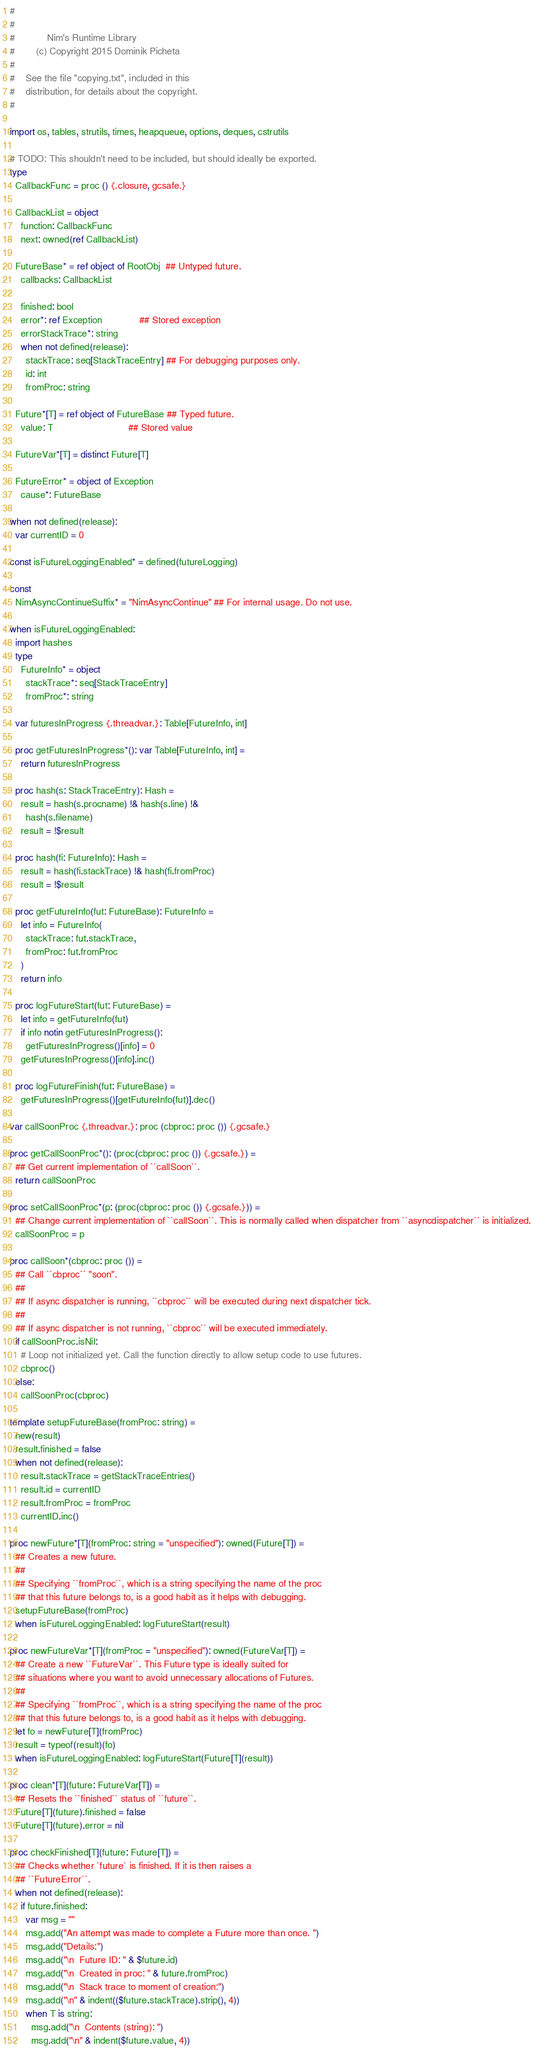<code> <loc_0><loc_0><loc_500><loc_500><_Nim_>#
#
#            Nim's Runtime Library
#        (c) Copyright 2015 Dominik Picheta
#
#    See the file "copying.txt", included in this
#    distribution, for details about the copyright.
#

import os, tables, strutils, times, heapqueue, options, deques, cstrutils

# TODO: This shouldn't need to be included, but should ideally be exported.
type
  CallbackFunc = proc () {.closure, gcsafe.}

  CallbackList = object
    function: CallbackFunc
    next: owned(ref CallbackList)

  FutureBase* = ref object of RootObj  ## Untyped future.
    callbacks: CallbackList

    finished: bool
    error*: ref Exception              ## Stored exception
    errorStackTrace*: string
    when not defined(release):
      stackTrace: seq[StackTraceEntry] ## For debugging purposes only.
      id: int
      fromProc: string

  Future*[T] = ref object of FutureBase ## Typed future.
    value: T                            ## Stored value

  FutureVar*[T] = distinct Future[T]

  FutureError* = object of Exception
    cause*: FutureBase

when not defined(release):
  var currentID = 0

const isFutureLoggingEnabled* = defined(futureLogging)

const
  NimAsyncContinueSuffix* = "NimAsyncContinue" ## For internal usage. Do not use.

when isFutureLoggingEnabled:
  import hashes
  type
    FutureInfo* = object
      stackTrace*: seq[StackTraceEntry]
      fromProc*: string

  var futuresInProgress {.threadvar.}: Table[FutureInfo, int]

  proc getFuturesInProgress*(): var Table[FutureInfo, int] =
    return futuresInProgress

  proc hash(s: StackTraceEntry): Hash =
    result = hash(s.procname) !& hash(s.line) !&
      hash(s.filename)
    result = !$result

  proc hash(fi: FutureInfo): Hash =
    result = hash(fi.stackTrace) !& hash(fi.fromProc)
    result = !$result

  proc getFutureInfo(fut: FutureBase): FutureInfo =
    let info = FutureInfo(
      stackTrace: fut.stackTrace,
      fromProc: fut.fromProc
    )
    return info

  proc logFutureStart(fut: FutureBase) =
    let info = getFutureInfo(fut)
    if info notin getFuturesInProgress():
      getFuturesInProgress()[info] = 0
    getFuturesInProgress()[info].inc()

  proc logFutureFinish(fut: FutureBase) =
    getFuturesInProgress()[getFutureInfo(fut)].dec()

var callSoonProc {.threadvar.}: proc (cbproc: proc ()) {.gcsafe.}

proc getCallSoonProc*(): (proc(cbproc: proc ()) {.gcsafe.}) =
  ## Get current implementation of ``callSoon``.
  return callSoonProc

proc setCallSoonProc*(p: (proc(cbproc: proc ()) {.gcsafe.})) =
  ## Change current implementation of ``callSoon``. This is normally called when dispatcher from ``asyncdispatcher`` is initialized.
  callSoonProc = p

proc callSoon*(cbproc: proc ()) =
  ## Call ``cbproc`` "soon".
  ##
  ## If async dispatcher is running, ``cbproc`` will be executed during next dispatcher tick.
  ##
  ## If async dispatcher is not running, ``cbproc`` will be executed immediately.
  if callSoonProc.isNil:
    # Loop not initialized yet. Call the function directly to allow setup code to use futures.
    cbproc()
  else:
    callSoonProc(cbproc)

template setupFutureBase(fromProc: string) =
  new(result)
  result.finished = false
  when not defined(release):
    result.stackTrace = getStackTraceEntries()
    result.id = currentID
    result.fromProc = fromProc
    currentID.inc()

proc newFuture*[T](fromProc: string = "unspecified"): owned(Future[T]) =
  ## Creates a new future.
  ##
  ## Specifying ``fromProc``, which is a string specifying the name of the proc
  ## that this future belongs to, is a good habit as it helps with debugging.
  setupFutureBase(fromProc)
  when isFutureLoggingEnabled: logFutureStart(result)

proc newFutureVar*[T](fromProc = "unspecified"): owned(FutureVar[T]) =
  ## Create a new ``FutureVar``. This Future type is ideally suited for
  ## situations where you want to avoid unnecessary allocations of Futures.
  ##
  ## Specifying ``fromProc``, which is a string specifying the name of the proc
  ## that this future belongs to, is a good habit as it helps with debugging.
  let fo = newFuture[T](fromProc)
  result = typeof(result)(fo)
  when isFutureLoggingEnabled: logFutureStart(Future[T](result))

proc clean*[T](future: FutureVar[T]) =
  ## Resets the ``finished`` status of ``future``.
  Future[T](future).finished = false
  Future[T](future).error = nil

proc checkFinished[T](future: Future[T]) =
  ## Checks whether `future` is finished. If it is then raises a
  ## ``FutureError``.
  when not defined(release):
    if future.finished:
      var msg = ""
      msg.add("An attempt was made to complete a Future more than once. ")
      msg.add("Details:")
      msg.add("\n  Future ID: " & $future.id)
      msg.add("\n  Created in proc: " & future.fromProc)
      msg.add("\n  Stack trace to moment of creation:")
      msg.add("\n" & indent(($future.stackTrace).strip(), 4))
      when T is string:
        msg.add("\n  Contents (string): ")
        msg.add("\n" & indent($future.value, 4))</code> 